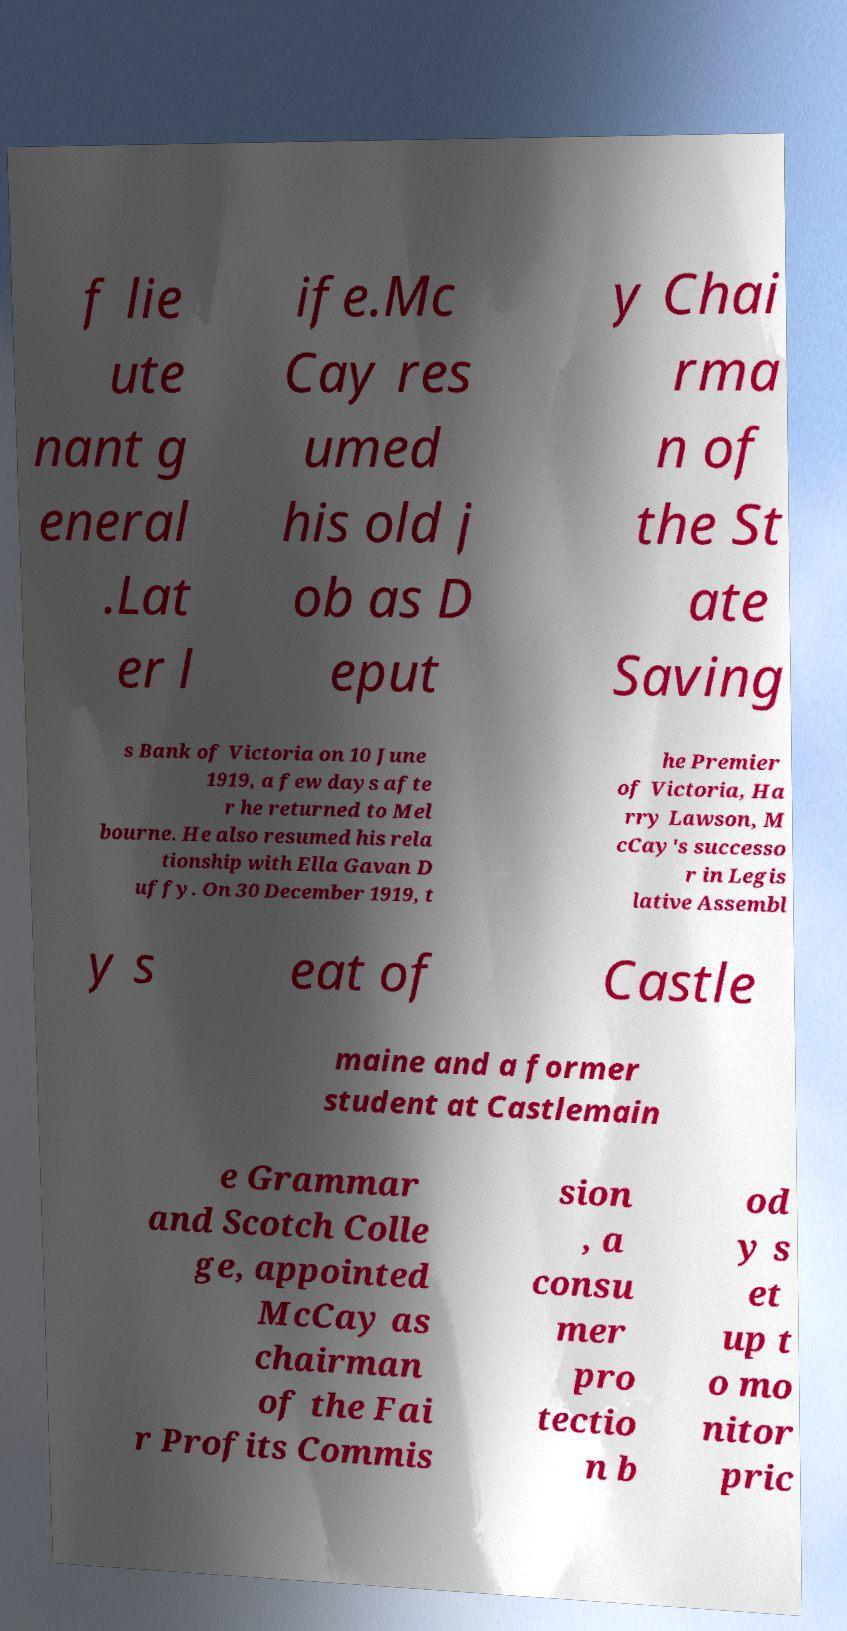Could you extract and type out the text from this image? f lie ute nant g eneral .Lat er l ife.Mc Cay res umed his old j ob as D eput y Chai rma n of the St ate Saving s Bank of Victoria on 10 June 1919, a few days afte r he returned to Mel bourne. He also resumed his rela tionship with Ella Gavan D uffy. On 30 December 1919, t he Premier of Victoria, Ha rry Lawson, M cCay's successo r in Legis lative Assembl y s eat of Castle maine and a former student at Castlemain e Grammar and Scotch Colle ge, appointed McCay as chairman of the Fai r Profits Commis sion , a consu mer pro tectio n b od y s et up t o mo nitor pric 